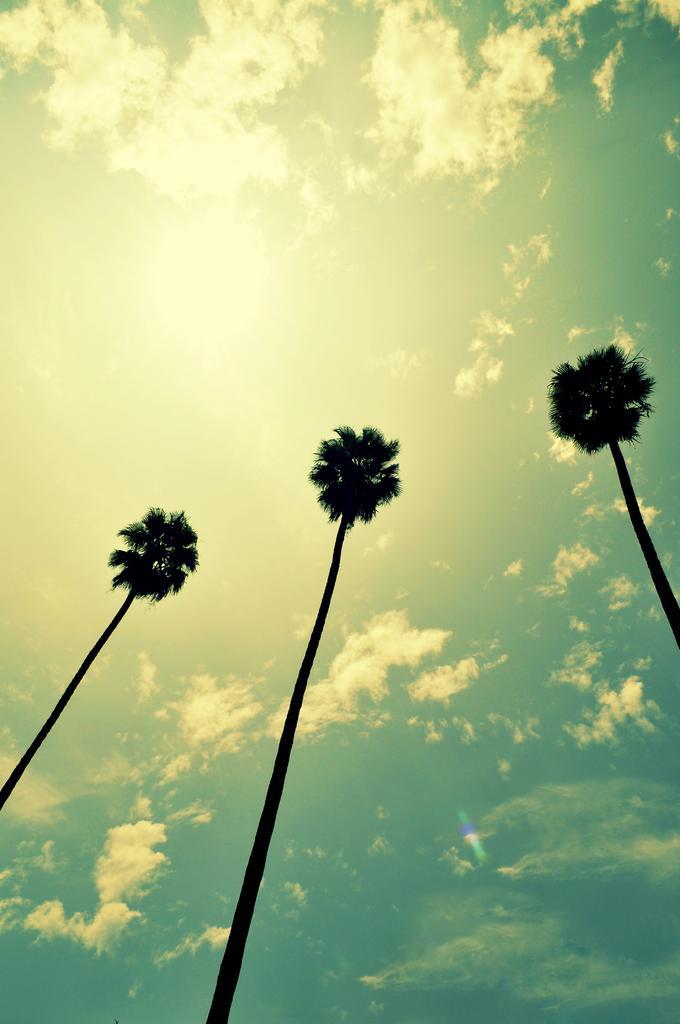Could you give a brief overview of what you see in this image? The picture consists of palm trees. At the top it is sky, sky is sunny. 